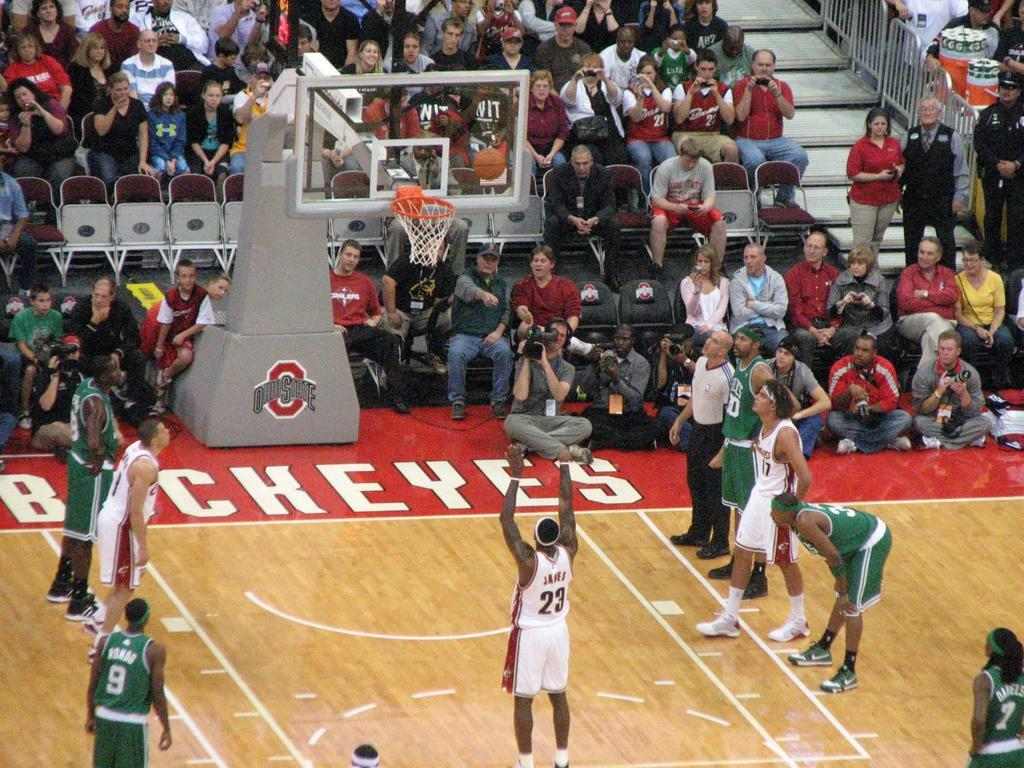<image>
Offer a succinct explanation of the picture presented. An Ohio State basketball player shoots from the free throw line. 